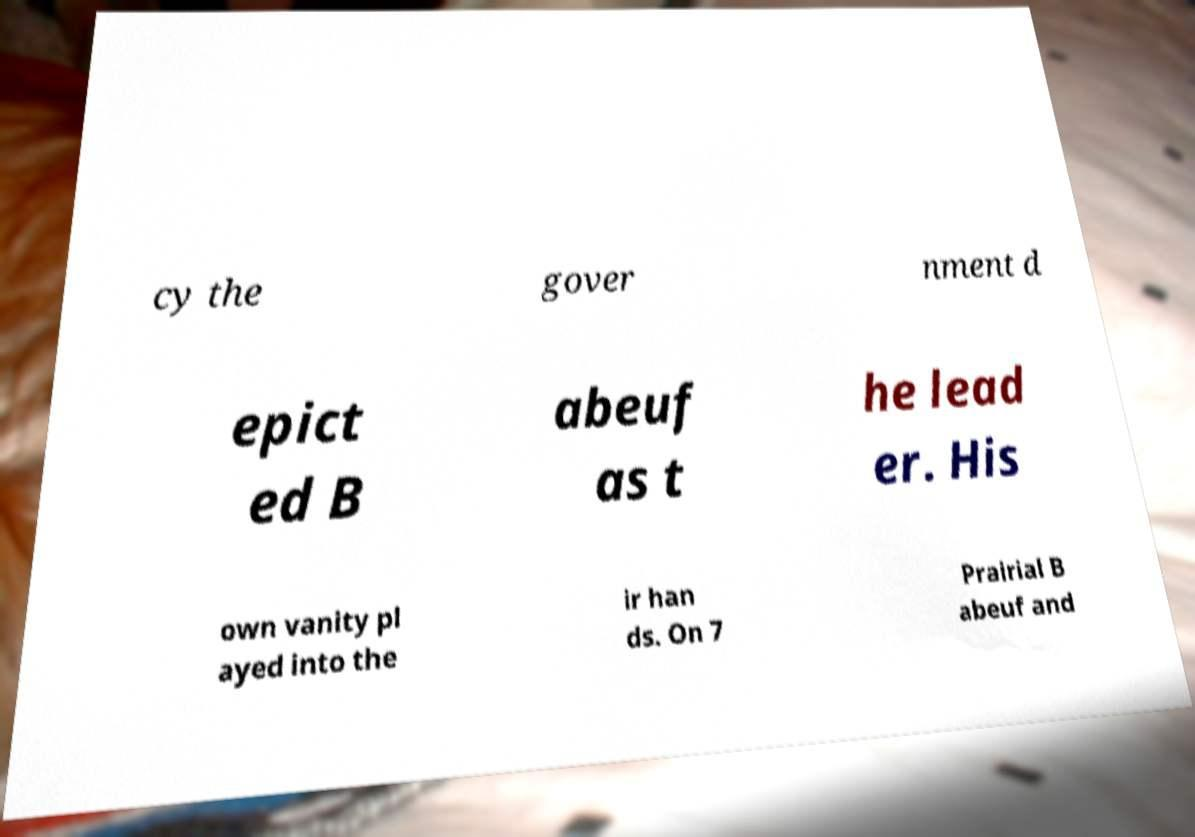Can you read and provide the text displayed in the image?This photo seems to have some interesting text. Can you extract and type it out for me? cy the gover nment d epict ed B abeuf as t he lead er. His own vanity pl ayed into the ir han ds. On 7 Prairial B abeuf and 